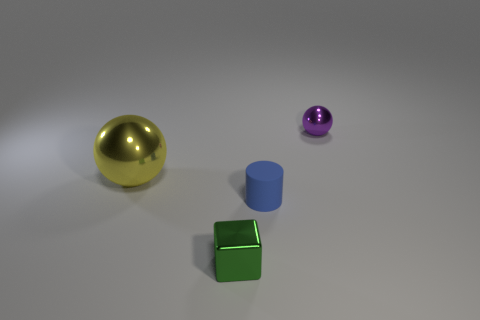Are there more tiny things that are behind the small blue matte cylinder than tiny yellow objects?
Provide a short and direct response. Yes. Are there any shiny cylinders?
Provide a short and direct response. No. Is the color of the large shiny object the same as the tiny block?
Ensure brevity in your answer.  No. How many big objects are either green metallic blocks or cyan rubber things?
Keep it short and to the point. 0. Is there anything else of the same color as the tiny matte cylinder?
Give a very brief answer. No. What is the shape of the yellow object that is the same material as the purple ball?
Ensure brevity in your answer.  Sphere. How big is the sphere that is right of the yellow shiny sphere?
Offer a terse response. Small. There is a rubber thing; what shape is it?
Ensure brevity in your answer.  Cylinder. Is the size of the shiny ball to the right of the shiny block the same as the thing to the left of the metallic block?
Your answer should be very brief. No. There is a ball on the right side of the small metal object in front of the metallic object right of the small metallic cube; how big is it?
Provide a succinct answer. Small. 